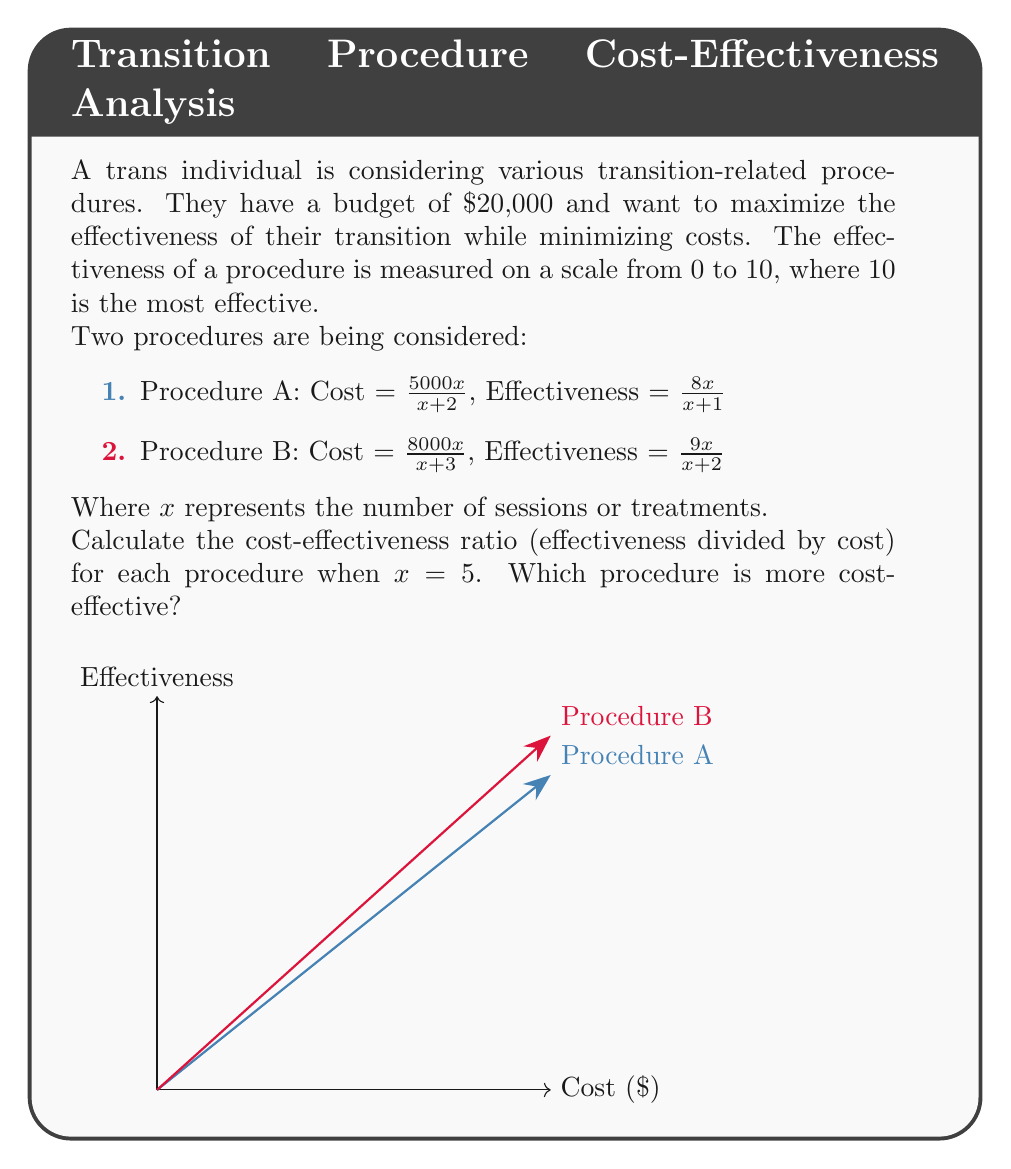Could you help me with this problem? Let's approach this step-by-step:

1) First, we need to calculate the cost and effectiveness for each procedure when $x = 5$.

For Procedure A:
Cost: $\frac{5000x}{x+2} = \frac{5000(5)}{5+2} = \frac{25000}{7} \approx 3571.43$
Effectiveness: $\frac{8x}{x+1} = \frac{8(5)}{5+1} = \frac{40}{6} \approx 6.67$

For Procedure B:
Cost: $\frac{8000x}{x+3} = \frac{8000(5)}{5+3} = \frac{40000}{8} = 5000$
Effectiveness: $\frac{9x}{x+2} = \frac{9(5)}{5+2} = \frac{45}{7} \approx 6.43$

2) Now, we calculate the cost-effectiveness ratio for each procedure:

For Procedure A:
Cost-effectiveness ratio = $\frac{\text{Effectiveness}}{\text{Cost}} = \frac{6.67}{3571.43} \approx 0.001867$

For Procedure B:
Cost-effectiveness ratio = $\frac{\text{Effectiveness}}{\text{Cost}} = \frac{6.43}{5000} \approx 0.001286$

3) Comparing the ratios:
Procedure A has a higher cost-effectiveness ratio (0.001867 > 0.001286).
Answer: Procedure A is more cost-effective with a ratio of approximately 0.001867. 